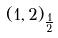<formula> <loc_0><loc_0><loc_500><loc_500>( 1 , 2 ) _ { \frac { 1 } { 2 } }</formula> 